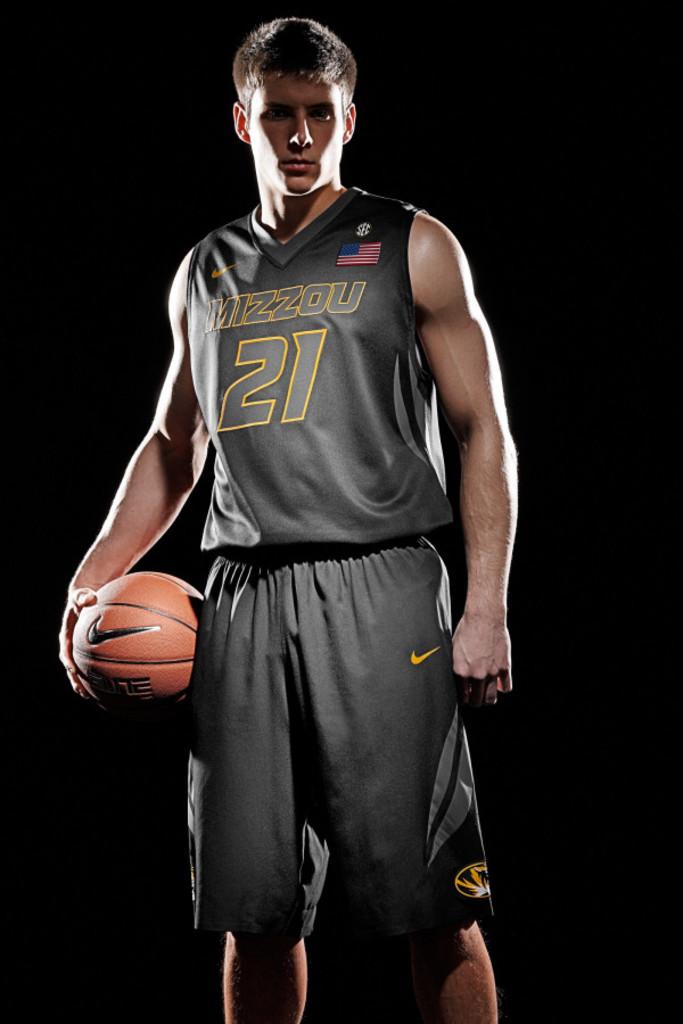What number is this basketball player?
Keep it short and to the point. 21. What kind of ball is he holding?
Your response must be concise. Answering does not require reading text in the image. 